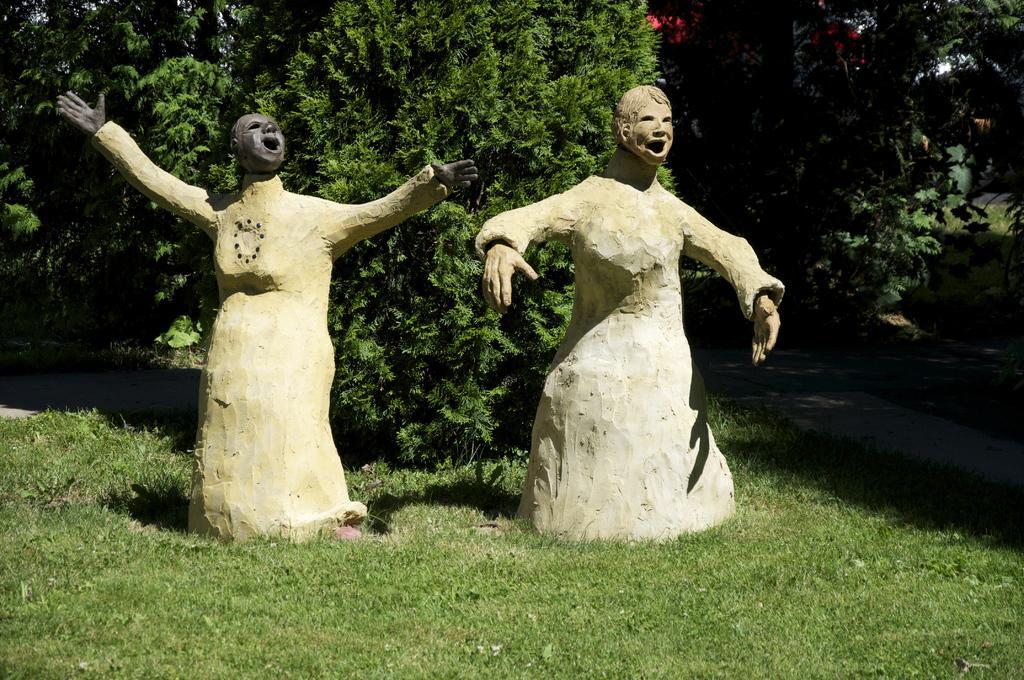Please provide a concise description of this image. In this picture we can see two statues, at the bottom there is grass, we can see trees in the background. 